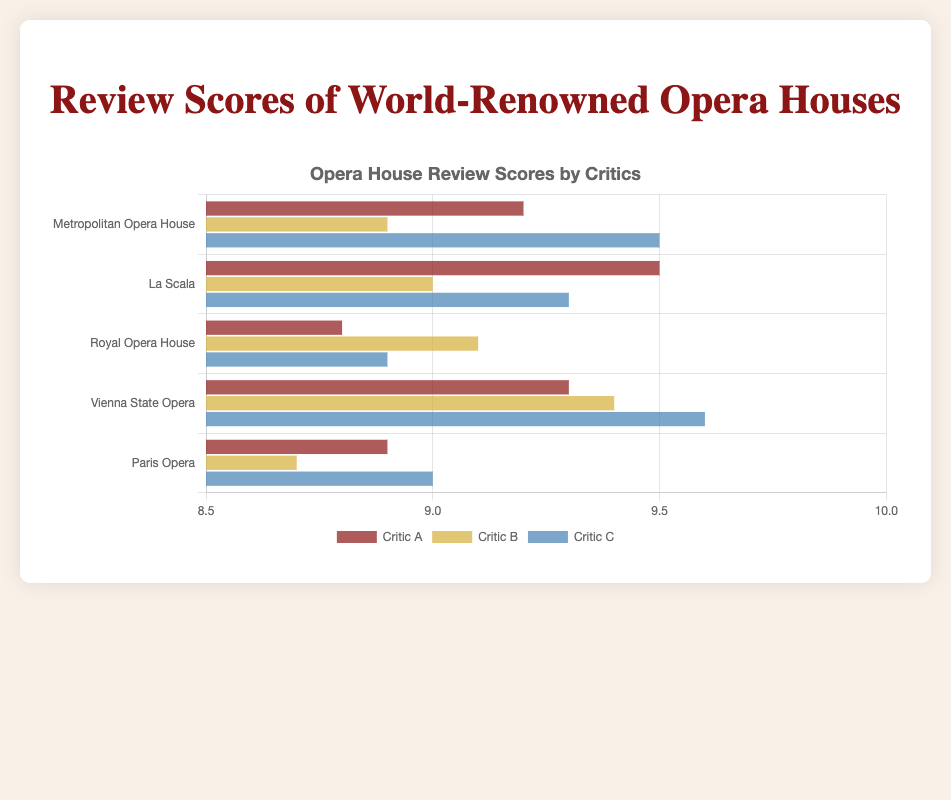Which critic gave the highest score to the Vienna State Opera? By visually comparing the lengths of the bars representing scores for Vienna State Opera, the longest bar is for Critic C, indicating the highest score of 9.6.
Answer: Critic C Which opera house received the lowest score from Critic B? By comparing the lengths of the bars representing Critic B's scores, Paris Opera has the shortest bar, which represents the score of 8.7.
Answer: Paris Opera What's the average score given by Critic C for all opera houses? To find the average, sum the scores given by Critic C to all opera houses and divide by the number of opera houses: (9.5 + 9.3 + 8.9 + 9.6 + 9.0) / 5 = 46.3 / 5 = 9.26.
Answer: 9.26 Which opera house received the most consistent scores across all critics? Consistency can be seen as bars of similar lengths. By visually inspecting the bar lengths, the Royal Opera House has scores 8.8, 9.1, and 8.9, showing high consistency.
Answer: Royal Opera House Which critic gave the highest overall average score across all opera houses? Calculate the average score for each critic:
(9.2 + 9.5 + 8.8 + 9.3 + 8.9) / 5 = 9.14 (Critic A), 
(8.9 + 9.0 + 9.1 + 9.4 + 8.7) / 5 = 9.02 (Critic B), 
(9.5 + 9.3 + 8.9 + 9.6 + 9.0) / 5 = 9.26 (Critic C). The highest average is from Critic C, 9.26.
Answer: Critic C Which opera house received the highest overall score from all critics? Sum the scores given by all critics to each opera house:
Metropolitan Opera House: 9.2 + 8.9 + 9.5 = 27.6,
La Scala: 9.5 + 9.0 + 9.3 = 27.8,
Royal Opera House: 8.8 + 9.1 + 8.9 = 26.8,
Vienna State Opera: 9.3 + 9.4 + 9.6 = 28.3,
Paris Opera: 8.9 + 8.7 + 9.0 = 26.6. The highest total score is for Vienna State Opera, 28.3.
Answer: Vienna State Opera What's the difference between the highest and lowest scores given by Critic A? The highest score given by Critic A is 9.5 (La Scala), and the lowest is 8.8 (Royal Opera House). The difference is 9.5 - 8.8 = 0.7.
Answer: 0.7 Which opera house received the highest score from any critic? By visually comparing all bars, the longest bar across all opera houses and critics represents Critic C's score of 9.6 for the Vienna State Opera.
Answer: Vienna State Opera Have any critics given the same score to more than one opera house? Visually compare bars for scores: Critic B gave a score of 9.0 to both La Scala and Royal Opera House.
Answer: Yes, Critic B 